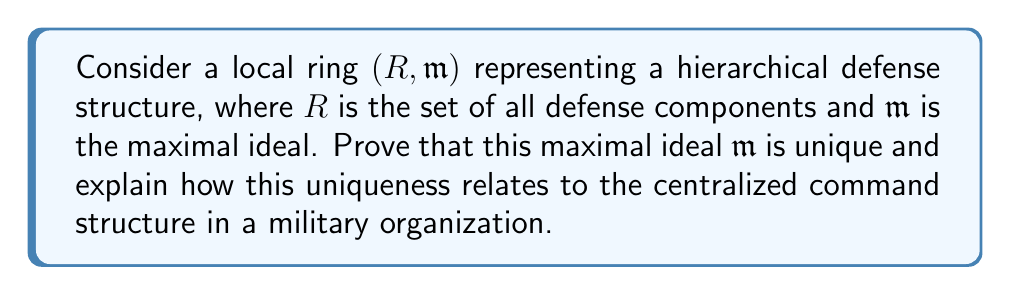Teach me how to tackle this problem. To prove the uniqueness of the maximal ideal in a local ring and relate it to a military hierarchy, we'll follow these steps:

1) First, recall that a local ring is defined as a ring with a unique maximal ideal. Let's prove this uniqueness.

2) Suppose, for contradiction, that $R$ has two distinct maximal ideals, $\mathfrak{m}_1$ and $\mathfrak{m}_2$.

3) In a local ring, every element not in the maximal ideal is a unit. Therefore, for any $x \in \mathfrak{m}_1 \setminus \mathfrak{m}_2$, $x$ must be a unit (since it's not in $\mathfrak{m}_2$).

4) However, if $x$ is a unit, then $\mathfrak{m}_1 = R$, contradicting the fact that $\mathfrak{m}_1$ is a proper ideal.

5) Thus, we must have $\mathfrak{m}_1 \subseteq \mathfrak{m}_2$. By the same argument, we can show $\mathfrak{m}_2 \subseteq \mathfrak{m}_1$.

6) Therefore, $\mathfrak{m}_1 = \mathfrak{m}_2$, proving the uniqueness of the maximal ideal.

Relating this to a military hierarchy:

7) The unique maximal ideal $\mathfrak{m}$ represents the highest level of command in the military structure. All other elements (lower ranks and units) are either in this ideal or are units (directly reportable to the highest command).

8) The uniqueness of $\mathfrak{m}$ ensures a single, unified chain of command, preventing conflicting orders or parallel power structures.

9) Elements not in $\mathfrak{m}$ (the units of the ring) represent the various operational components that can be directly mobilized by the highest command.

10) The fact that every proper ideal is contained in $\mathfrak{m}$ mirrors how all subordinate units ultimately report to the central command structure.

This mathematical structure thus provides a robust model for a centralized, hierarchical defense organization, emphasizing the importance of a clear, unique chain of command in maintaining a strong defense.
Answer: The maximal ideal $\mathfrak{m}$ in a local ring $(R, \mathfrak{m})$ is unique. This uniqueness mathematically represents the singular, centralized command structure essential for maintaining a strong, coordinated defense in a military organization. 